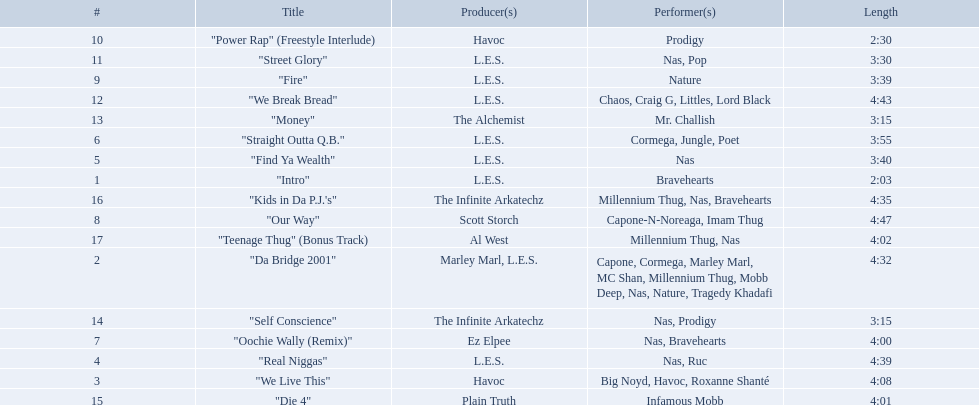What are the track lengths on the album? 2:03, 4:32, 4:08, 4:39, 3:40, 3:55, 4:00, 4:47, 3:39, 2:30, 3:30, 4:43, 3:15, 3:15, 4:01, 4:35, 4:02. What is the longest length? 4:47. 